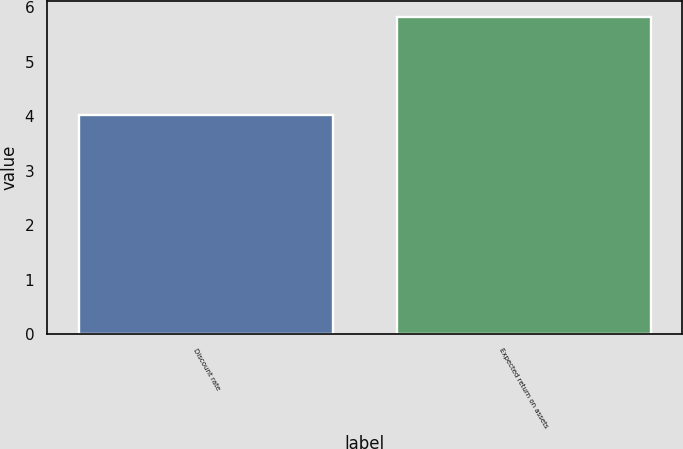<chart> <loc_0><loc_0><loc_500><loc_500><bar_chart><fcel>Discount rate<fcel>Expected return on assets<nl><fcel>4.02<fcel>5.83<nl></chart> 